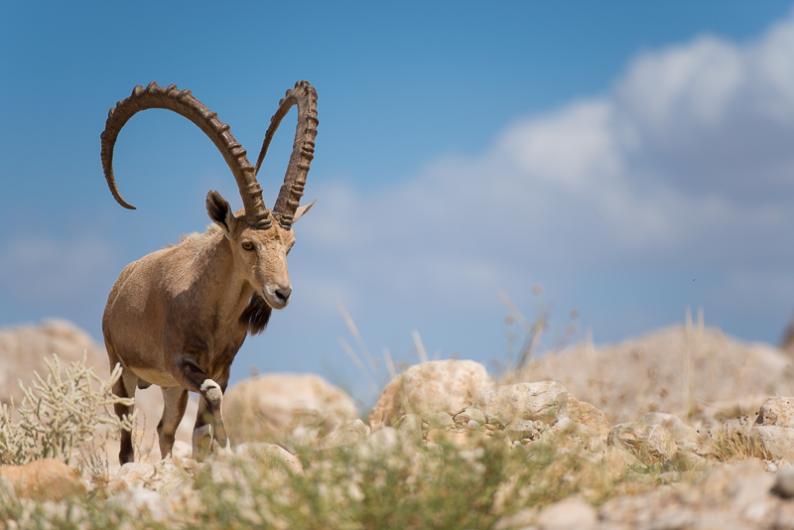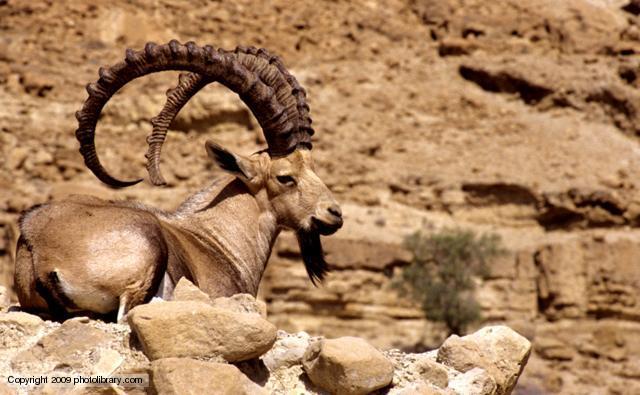The first image is the image on the left, the second image is the image on the right. Assess this claim about the two images: "One of the paired images features exactly two animals.". Correct or not? Answer yes or no. No. 